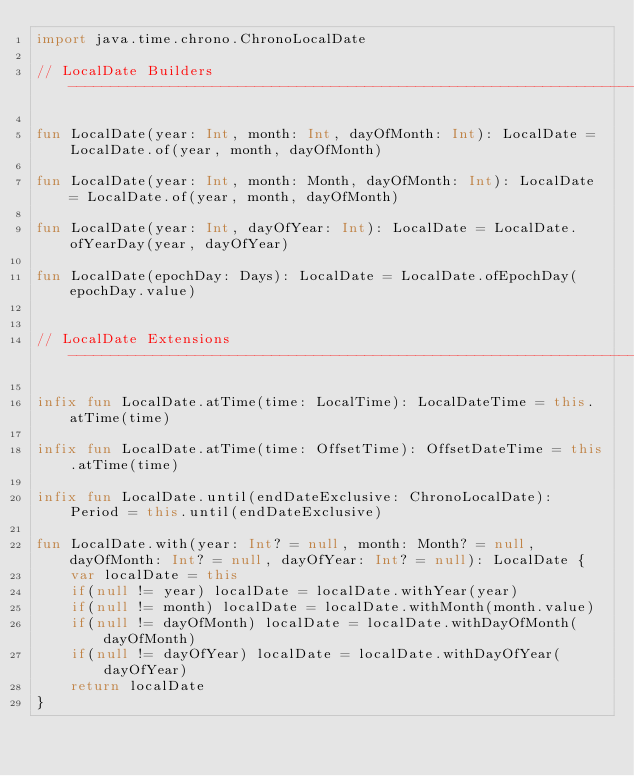Convert code to text. <code><loc_0><loc_0><loc_500><loc_500><_Kotlin_>import java.time.chrono.ChronoLocalDate

// LocalDate Builders  -------------------------------------------------------------------------------------------------

fun LocalDate(year: Int, month: Int, dayOfMonth: Int): LocalDate = LocalDate.of(year, month, dayOfMonth)

fun LocalDate(year: Int, month: Month, dayOfMonth: Int): LocalDate = LocalDate.of(year, month, dayOfMonth)

fun LocalDate(year: Int, dayOfYear: Int): LocalDate = LocalDate.ofYearDay(year, dayOfYear)

fun LocalDate(epochDay: Days): LocalDate = LocalDate.ofEpochDay(epochDay.value)


// LocalDate Extensions  -----------------------------------------------------------------------------------------------

infix fun LocalDate.atTime(time: LocalTime): LocalDateTime = this.atTime(time)

infix fun LocalDate.atTime(time: OffsetTime): OffsetDateTime = this.atTime(time)

infix fun LocalDate.until(endDateExclusive: ChronoLocalDate): Period = this.until(endDateExclusive)

fun LocalDate.with(year: Int? = null, month: Month? = null, dayOfMonth: Int? = null, dayOfYear: Int? = null): LocalDate {
    var localDate = this
    if(null != year) localDate = localDate.withYear(year)
    if(null != month) localDate = localDate.withMonth(month.value)
    if(null != dayOfMonth) localDate = localDate.withDayOfMonth(dayOfMonth)
    if(null != dayOfYear) localDate = localDate.withDayOfYear(dayOfYear)
    return localDate
}</code> 